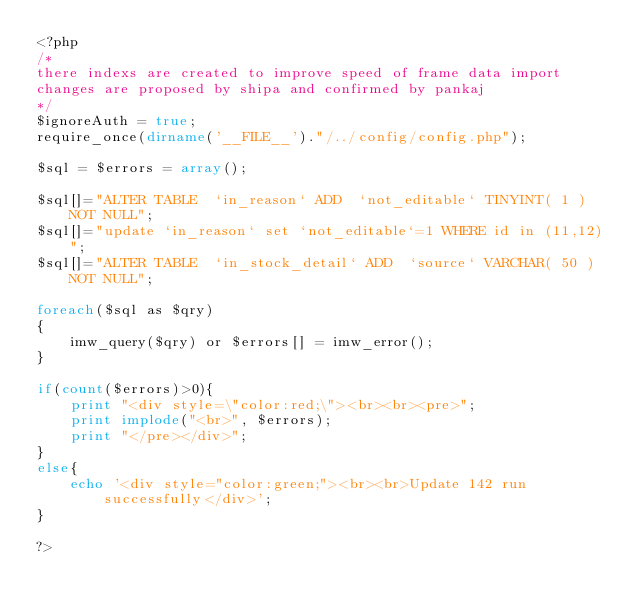<code> <loc_0><loc_0><loc_500><loc_500><_PHP_><?php 
/*
there indexs are created to improve speed of frame data import
changes are proposed by shipa and confirmed by pankaj
*/	
$ignoreAuth = true;
require_once(dirname('__FILE__')."/../config/config.php");

$sql = $errors = array();

$sql[]="ALTER TABLE  `in_reason` ADD  `not_editable` TINYINT( 1 ) NOT NULL";
$sql[]="update `in_reason` set `not_editable`=1 WHERE id in (11,12)";
$sql[]="ALTER TABLE  `in_stock_detail` ADD  `source` VARCHAR( 50 ) NOT NULL";

foreach($sql as $qry)
{
	imw_query($qry) or $errors[] = imw_error();
}

if(count($errors)>0){
	print "<div style=\"color:red;\"><br><br><pre>";
	print implode("<br>", $errors);
	print "</pre></div>";
}
else{
    echo '<div style="color:green;"><br><br>Update 142 run successfully</div>';
}

?>
</code> 